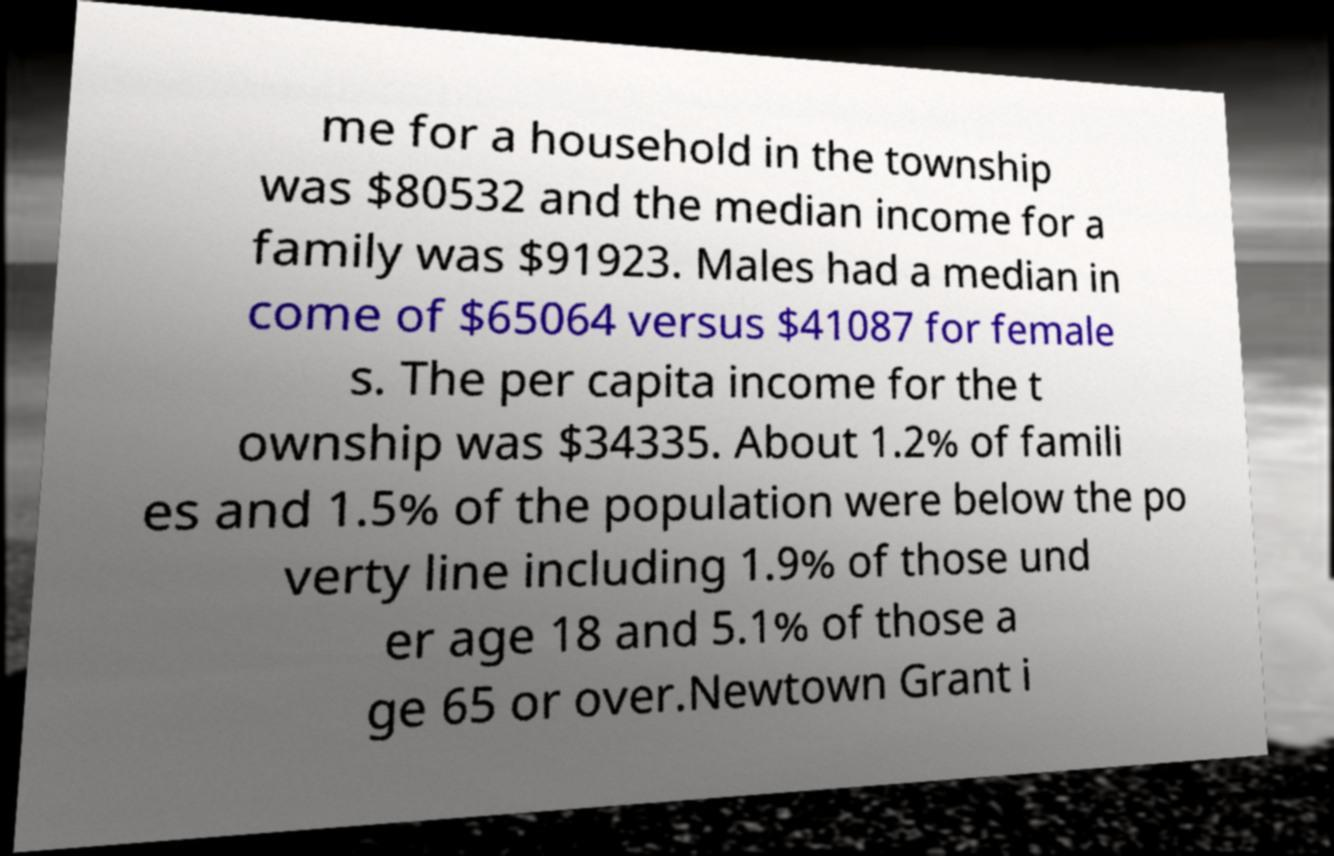Please identify and transcribe the text found in this image. me for a household in the township was $80532 and the median income for a family was $91923. Males had a median in come of $65064 versus $41087 for female s. The per capita income for the t ownship was $34335. About 1.2% of famili es and 1.5% of the population were below the po verty line including 1.9% of those und er age 18 and 5.1% of those a ge 65 or over.Newtown Grant i 